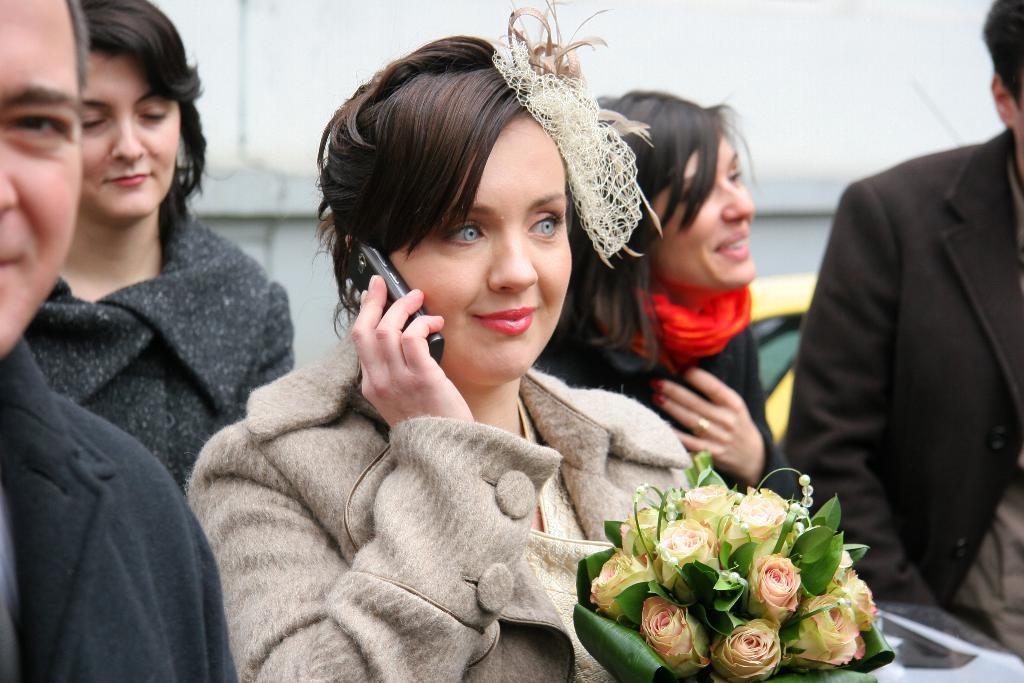Could you give a brief overview of what you see in this image? In this image I can see five persons, bouquet and a wall. This image is taken may be during a day. 